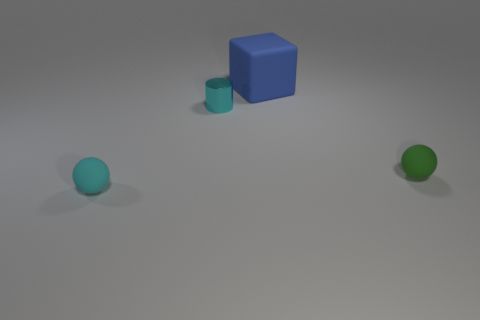Add 1 big green metallic blocks. How many objects exist? 5 Subtract all cylinders. How many objects are left? 3 Subtract all large rubber things. Subtract all green balls. How many objects are left? 2 Add 1 tiny balls. How many tiny balls are left? 3 Add 2 big green metallic balls. How many big green metallic balls exist? 2 Subtract 0 purple spheres. How many objects are left? 4 